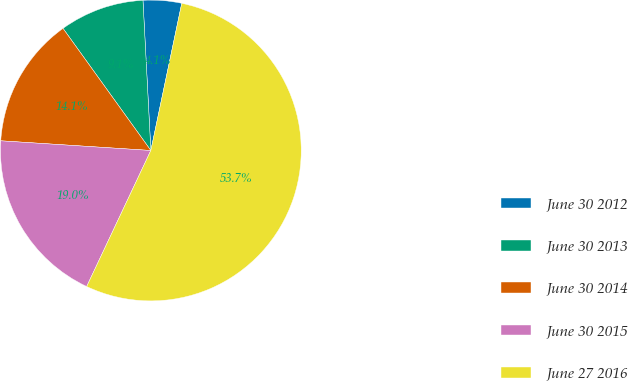<chart> <loc_0><loc_0><loc_500><loc_500><pie_chart><fcel>June 30 2012<fcel>June 30 2013<fcel>June 30 2014<fcel>June 30 2015<fcel>June 27 2016<nl><fcel>4.13%<fcel>9.09%<fcel>14.05%<fcel>19.01%<fcel>53.72%<nl></chart> 